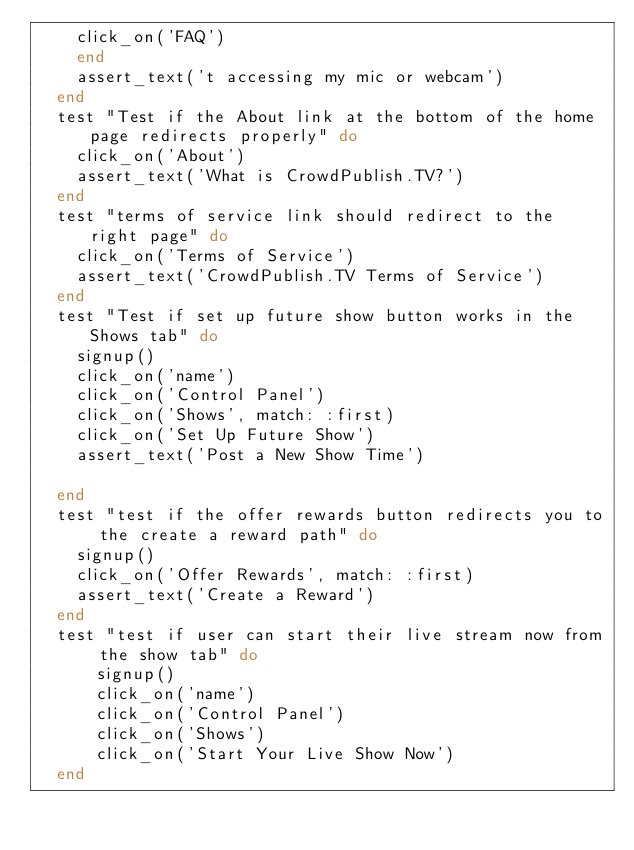Convert code to text. <code><loc_0><loc_0><loc_500><loc_500><_Ruby_>    click_on('FAQ')
    end
    assert_text('t accessing my mic or webcam')
  end
  test "Test if the About link at the bottom of the home page redirects properly" do
    click_on('About')
    assert_text('What is CrowdPublish.TV?')
  end
  test "terms of service link should redirect to the right page" do
    click_on('Terms of Service')
    assert_text('CrowdPublish.TV Terms of Service')
  end
  test "Test if set up future show button works in the Shows tab" do
    signup()
    click_on('name')
    click_on('Control Panel')
    click_on('Shows', match: :first)
    click_on('Set Up Future Show')
    assert_text('Post a New Show Time')
      
  end
  test "test if the offer rewards button redirects you to the create a reward path" do
    signup()
    click_on('Offer Rewards', match: :first)
    assert_text('Create a Reward')
  end
  test "test if user can start their live stream now from the show tab" do
      signup()
      click_on('name')
      click_on('Control Panel')
      click_on('Shows')
      click_on('Start Your Live Show Now')
  end</code> 